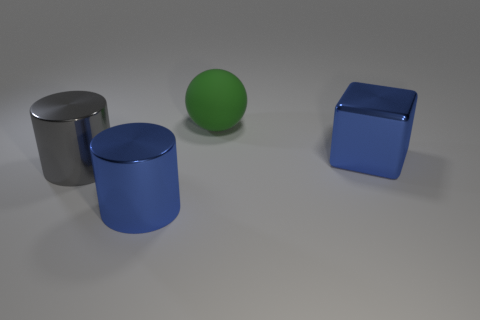What color is the shiny thing right of the large matte ball?
Make the answer very short. Blue. Is there a shiny block behind the large cylinder behind the large blue metallic thing to the left of the rubber object?
Provide a succinct answer. Yes. Are there more objects to the left of the big ball than large yellow shiny cubes?
Keep it short and to the point. Yes. Do the blue object left of the large rubber thing and the large gray object have the same shape?
Provide a succinct answer. Yes. Are there any other things that are the same material as the green ball?
Offer a terse response. No. What number of things are big spheres or blue shiny things that are in front of the big metal block?
Offer a terse response. 2. Are there more large cylinders that are left of the large blue metallic cylinder than big blue cylinders that are behind the gray shiny object?
Your response must be concise. Yes. Is the shape of the large gray thing the same as the blue metallic thing that is to the left of the big blue shiny block?
Provide a short and direct response. Yes. How many other objects are there of the same shape as the green object?
Offer a very short reply. 0. There is a big object that is both left of the green sphere and to the right of the gray cylinder; what is its color?
Offer a very short reply. Blue. 